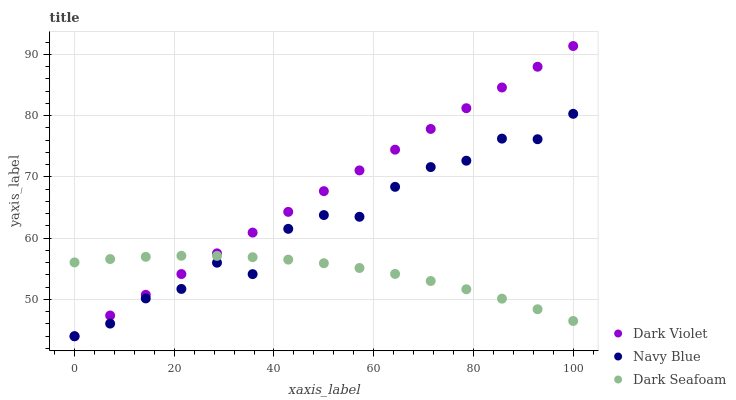Does Dark Seafoam have the minimum area under the curve?
Answer yes or no. Yes. Does Dark Violet have the maximum area under the curve?
Answer yes or no. Yes. Does Dark Violet have the minimum area under the curve?
Answer yes or no. No. Does Dark Seafoam have the maximum area under the curve?
Answer yes or no. No. Is Dark Violet the smoothest?
Answer yes or no. Yes. Is Navy Blue the roughest?
Answer yes or no. Yes. Is Dark Seafoam the smoothest?
Answer yes or no. No. Is Dark Seafoam the roughest?
Answer yes or no. No. Does Navy Blue have the lowest value?
Answer yes or no. Yes. Does Dark Seafoam have the lowest value?
Answer yes or no. No. Does Dark Violet have the highest value?
Answer yes or no. Yes. Does Dark Seafoam have the highest value?
Answer yes or no. No. Does Dark Violet intersect Navy Blue?
Answer yes or no. Yes. Is Dark Violet less than Navy Blue?
Answer yes or no. No. Is Dark Violet greater than Navy Blue?
Answer yes or no. No. 